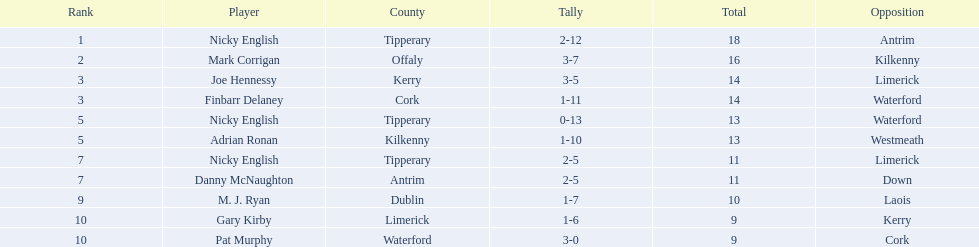Who was the top ranked player in a single game? Nicky English. 